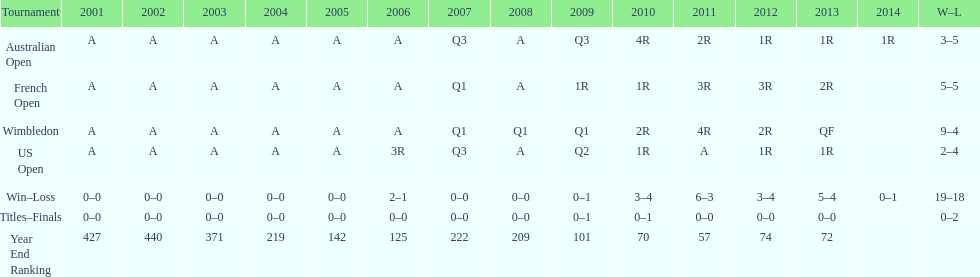In which year was the highest year-end ranking attained? 2011. 